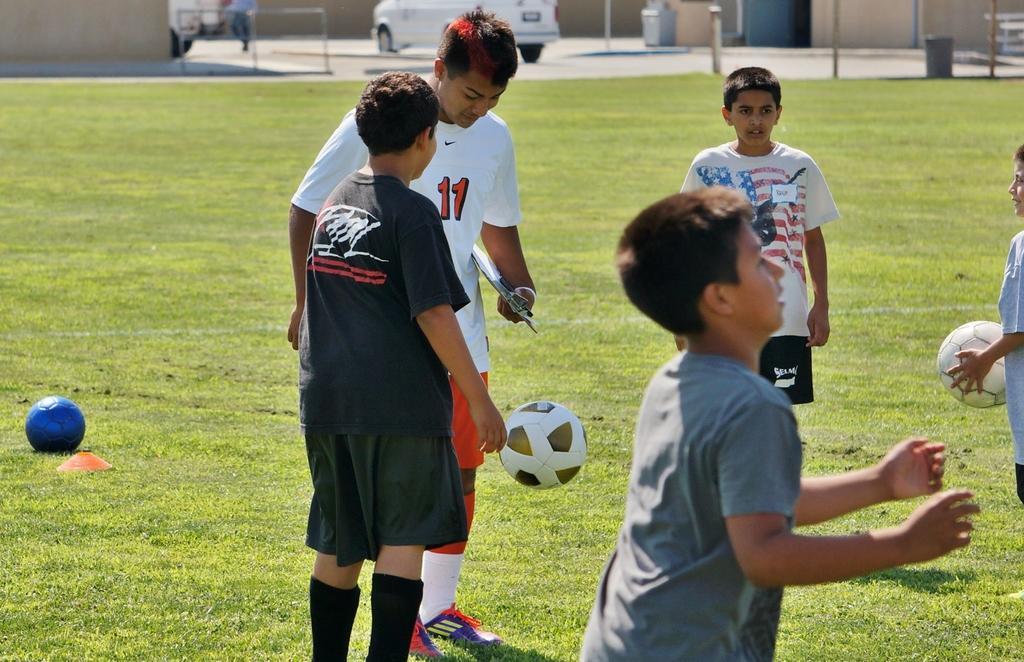Could you give a brief overview of what you see in this image? there are many children in the ground. 